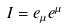Convert formula to latex. <formula><loc_0><loc_0><loc_500><loc_500>I = e _ { \mu } e ^ { \mu }</formula> 